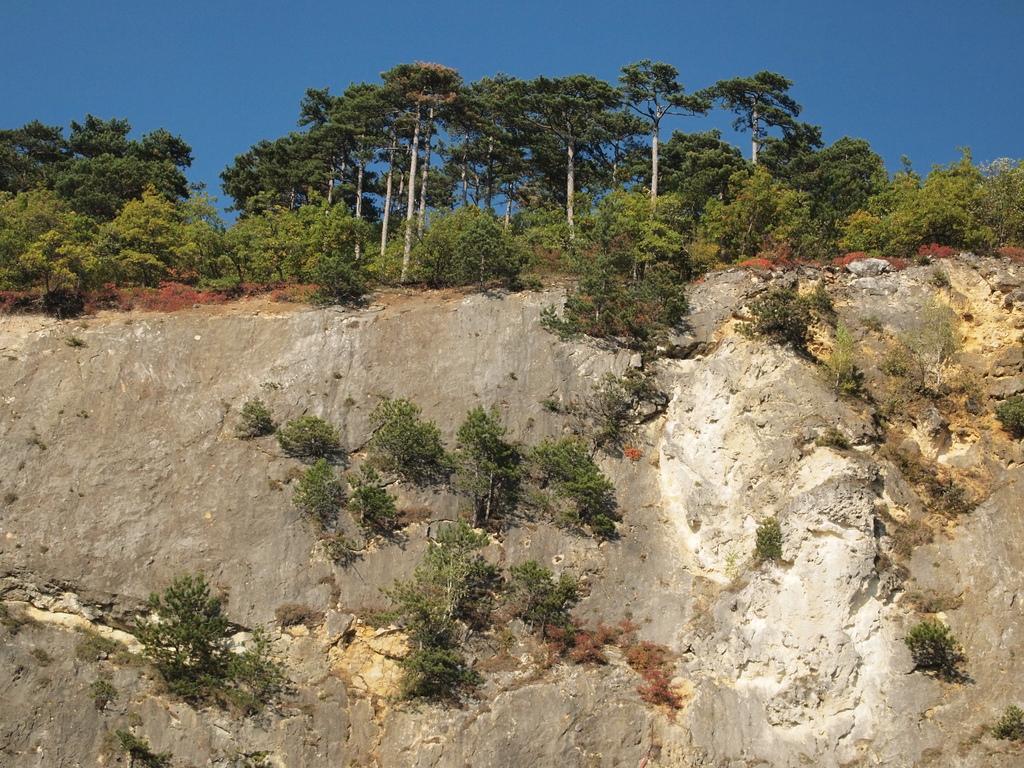In one or two sentences, can you explain what this image depicts? In the center of the image we can see the sky, trees, plants, stones and a few other objects. 